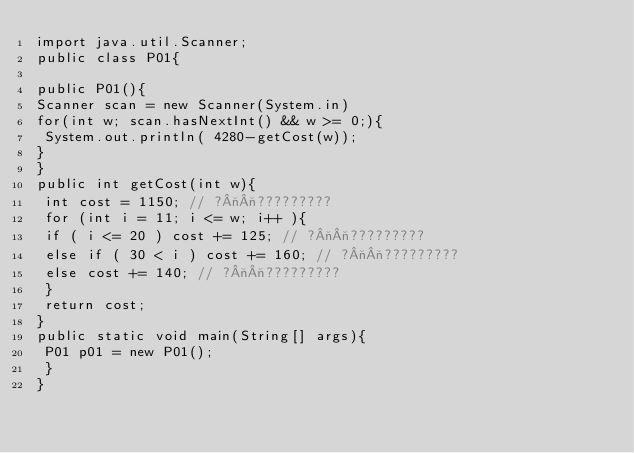<code> <loc_0><loc_0><loc_500><loc_500><_Java_>import java.util.Scanner;
public class P01{

public P01(){
Scanner scan = new Scanner(System.in)
for(int w; scan.hasNextInt() && w >= 0;){
 System.out.println( 4280-getCost(w));
}
}
public int getCost(int w){
 int cost = 1150; // ?¬¬?????????
 for (int i = 11; i <= w; i++ ){
 if ( i <= 20 ) cost += 125; // ?¬¬?????????
 else if ( 30 < i ) cost += 160; // ?¬¬?????????
 else cost += 140; // ?¬¬?????????
 }
 return cost;
}
public static void main(String[] args){
 P01 p01 = new P01();
 }
}</code> 